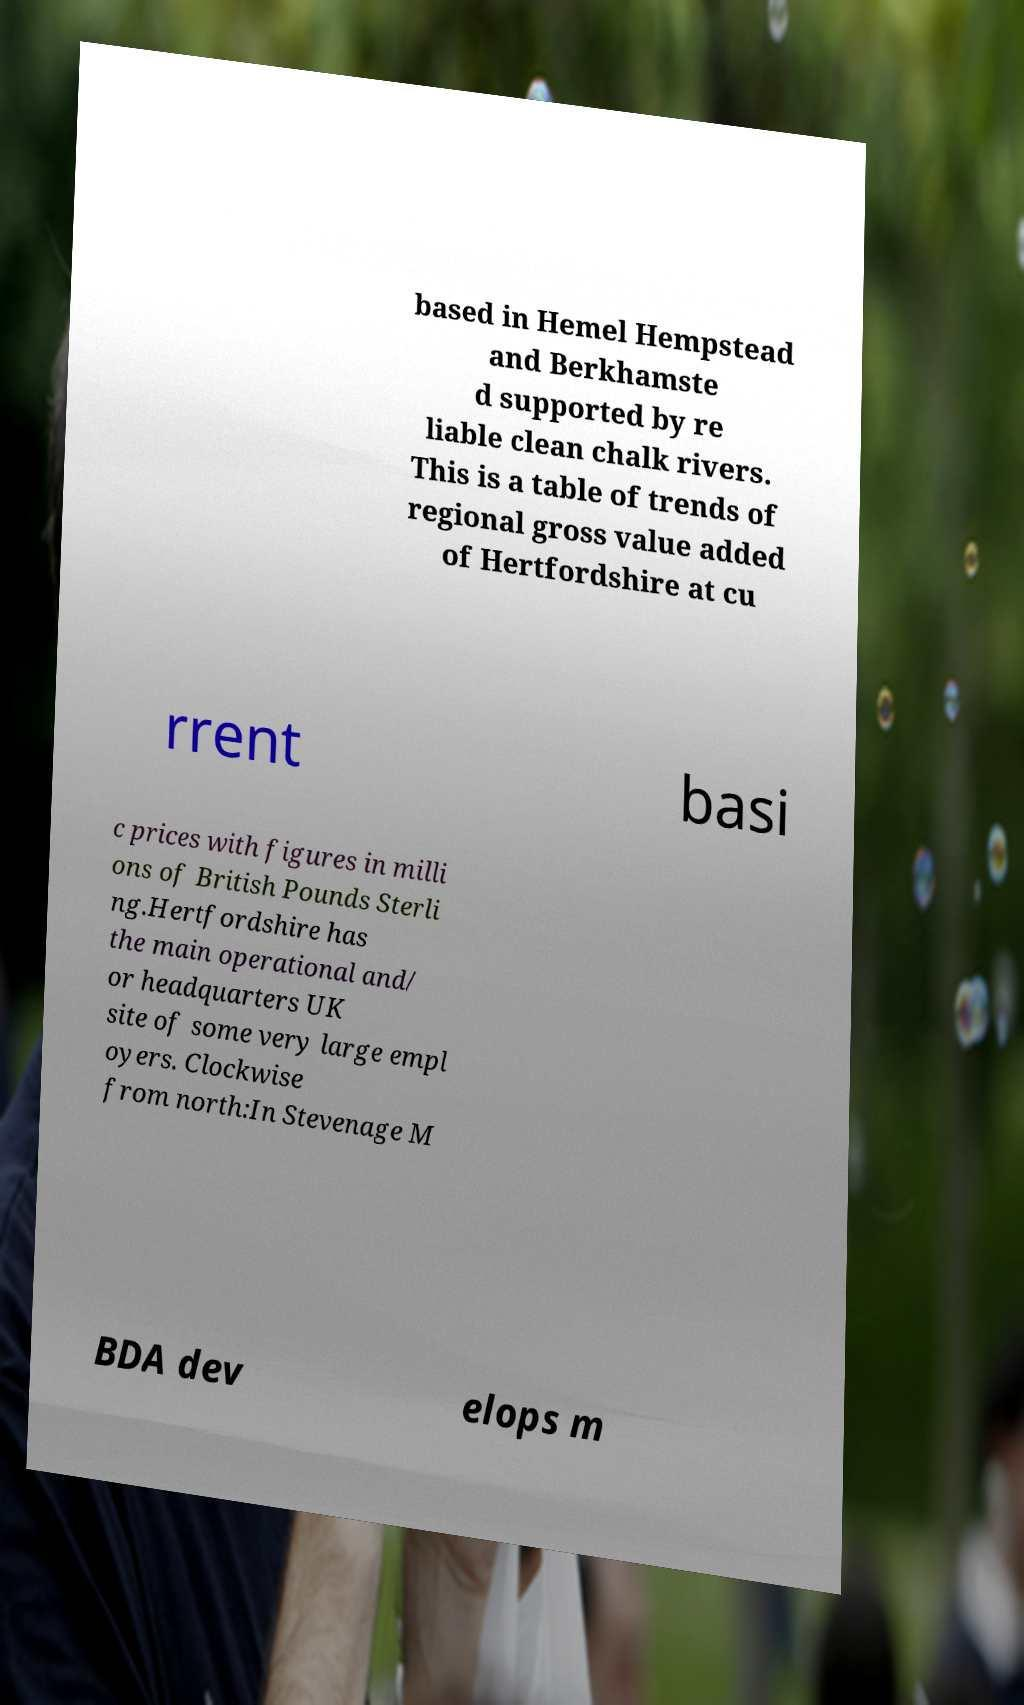What messages or text are displayed in this image? I need them in a readable, typed format. based in Hemel Hempstead and Berkhamste d supported by re liable clean chalk rivers. This is a table of trends of regional gross value added of Hertfordshire at cu rrent basi c prices with figures in milli ons of British Pounds Sterli ng.Hertfordshire has the main operational and/ or headquarters UK site of some very large empl oyers. Clockwise from north:In Stevenage M BDA dev elops m 